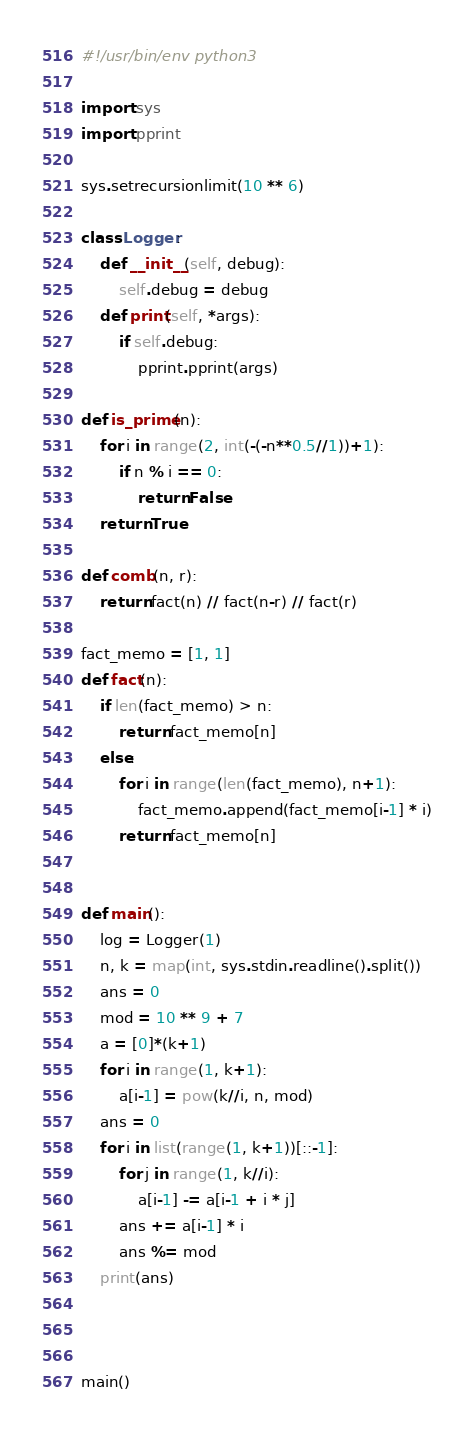Convert code to text. <code><loc_0><loc_0><loc_500><loc_500><_Python_>#!/usr/bin/env python3

import sys
import pprint

sys.setrecursionlimit(10 ** 6)

class Logger:
	def __init__(self, debug):
		self.debug = debug
	def print(self, *args):
		if self.debug:
			pprint.pprint(args)

def is_prime(n):
	for i in range(2, int(-(-n**0.5//1))+1):
		if n % i == 0:
			return False
	return True

def comb(n, r):
	return fact(n) // fact(n-r) // fact(r)

fact_memo = [1, 1]
def fact(n):
	if len(fact_memo) > n:
		return fact_memo[n]
	else:
		for i in range(len(fact_memo), n+1):
			fact_memo.append(fact_memo[i-1] * i)
		return fact_memo[n]


def main():
	log = Logger(1)
	n, k = map(int, sys.stdin.readline().split())
	ans = 0
	mod = 10 ** 9 + 7
	a = [0]*(k+1)
	for i in range(1, k+1):
		a[i-1] = pow(k//i, n, mod)
	ans = 0
	for i in list(range(1, k+1))[::-1]:
		for j in range(1, k//i):
			a[i-1] -= a[i-1 + i * j]
		ans += a[i-1] * i
		ans %= mod
	print(ans)



main()</code> 